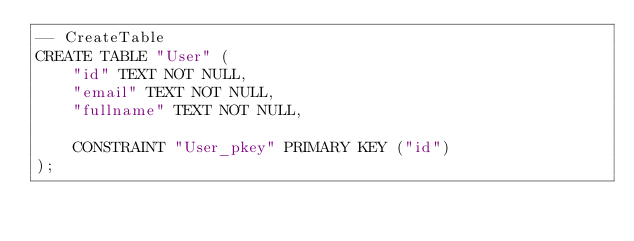<code> <loc_0><loc_0><loc_500><loc_500><_SQL_>-- CreateTable
CREATE TABLE "User" (
    "id" TEXT NOT NULL,
    "email" TEXT NOT NULL,
    "fullname" TEXT NOT NULL,

    CONSTRAINT "User_pkey" PRIMARY KEY ("id")
);
</code> 